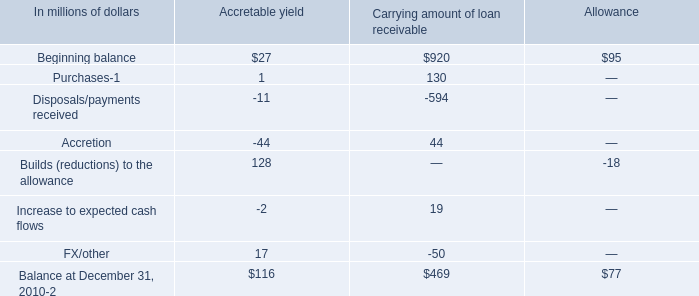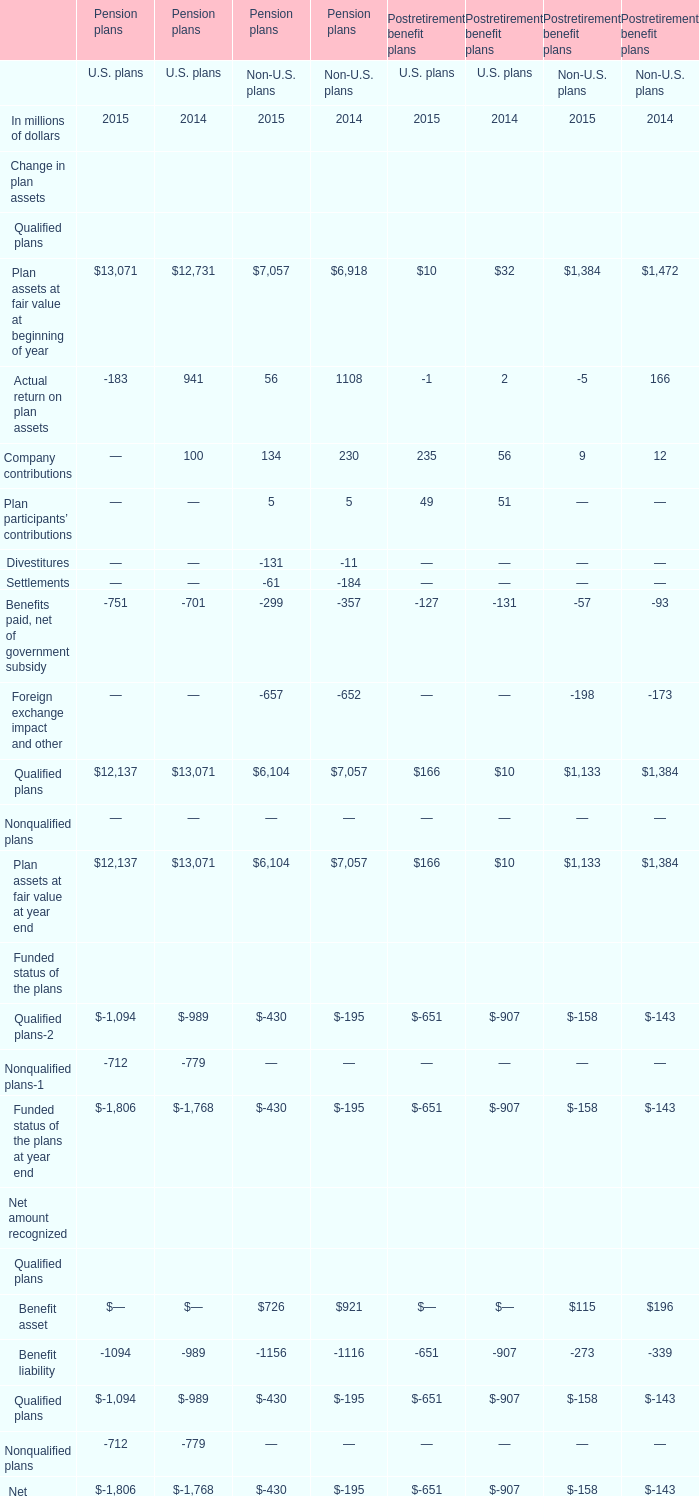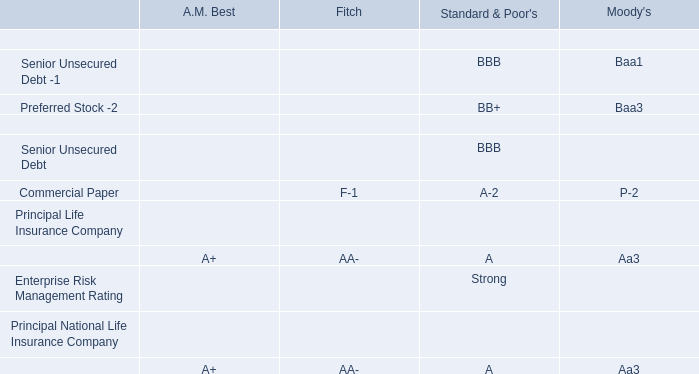what is the percentage of allowance of the company's purchased distressed loan portfolio at december 31 , 2010? 
Computations: (77 / (392 + 77))
Answer: 0.16418. 